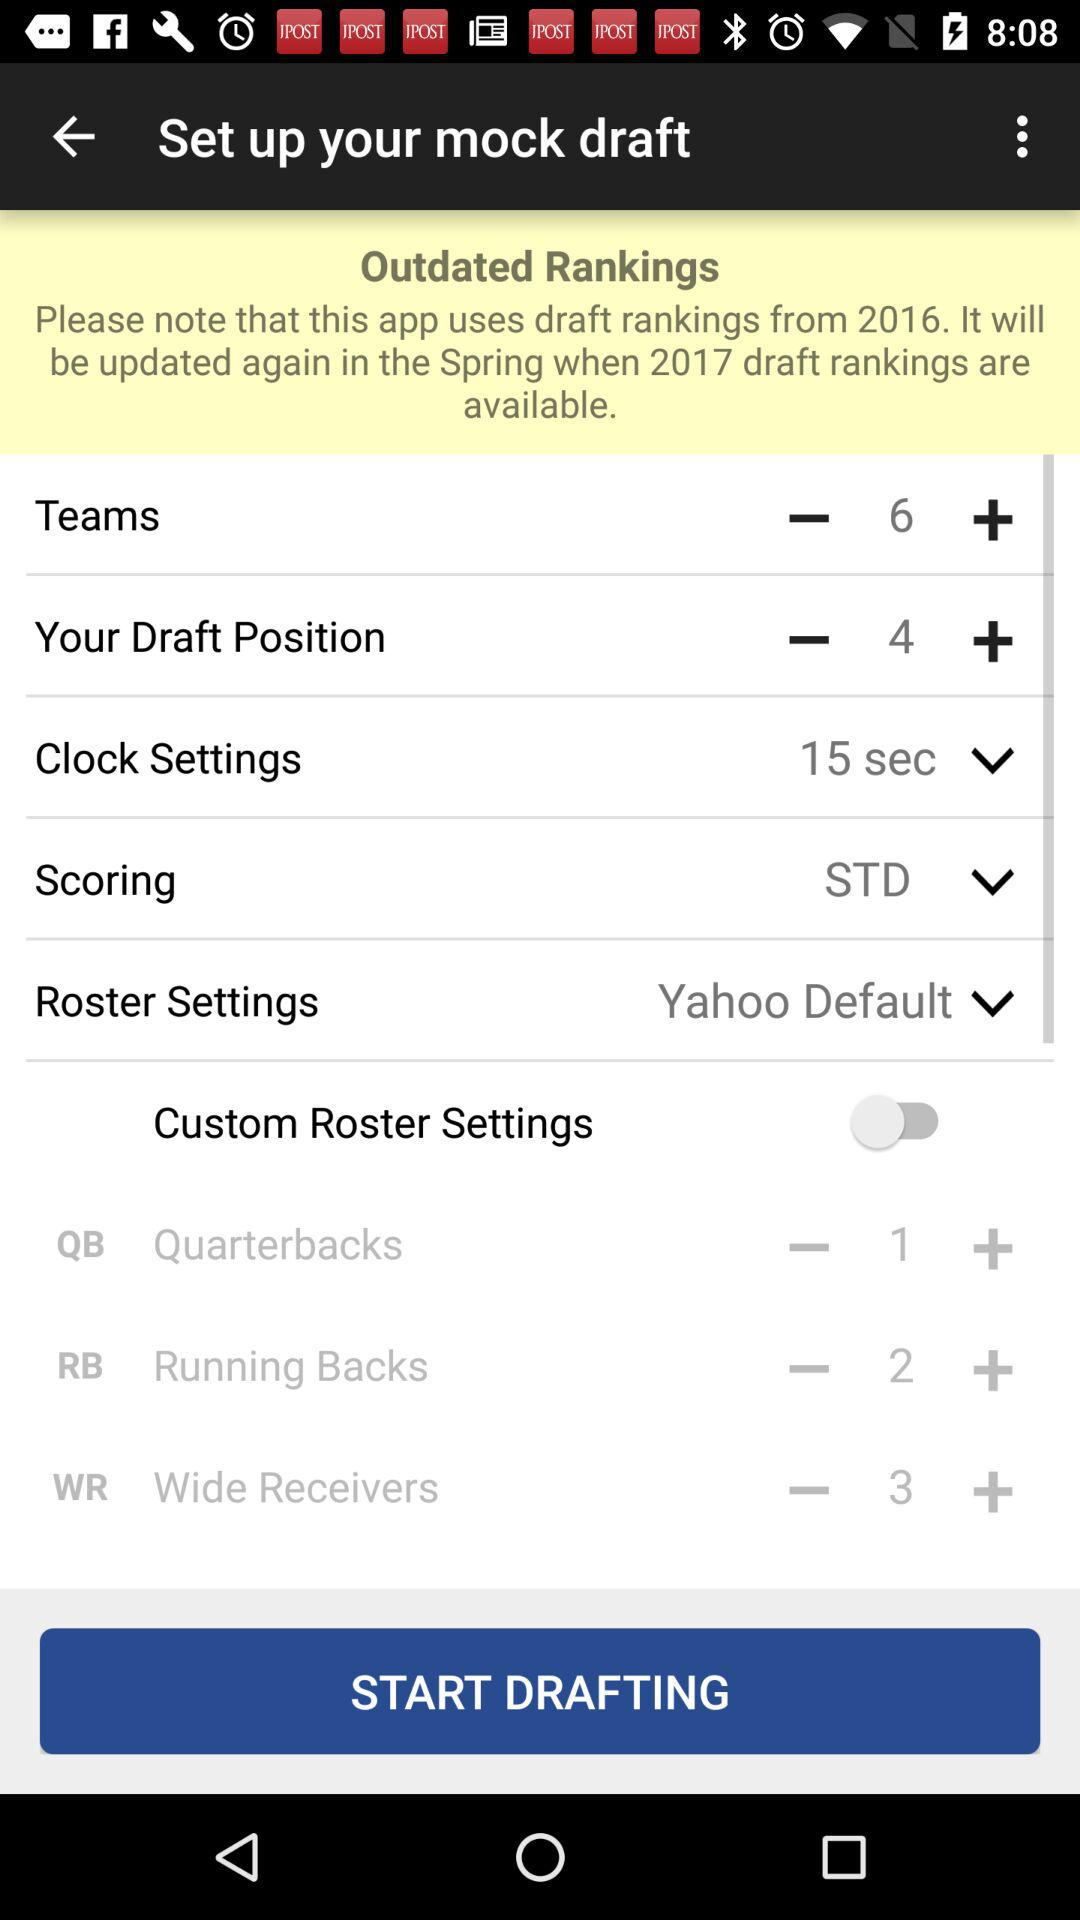How many more positions can be added than the current number of positions?
Answer the question using a single word or phrase. 3 